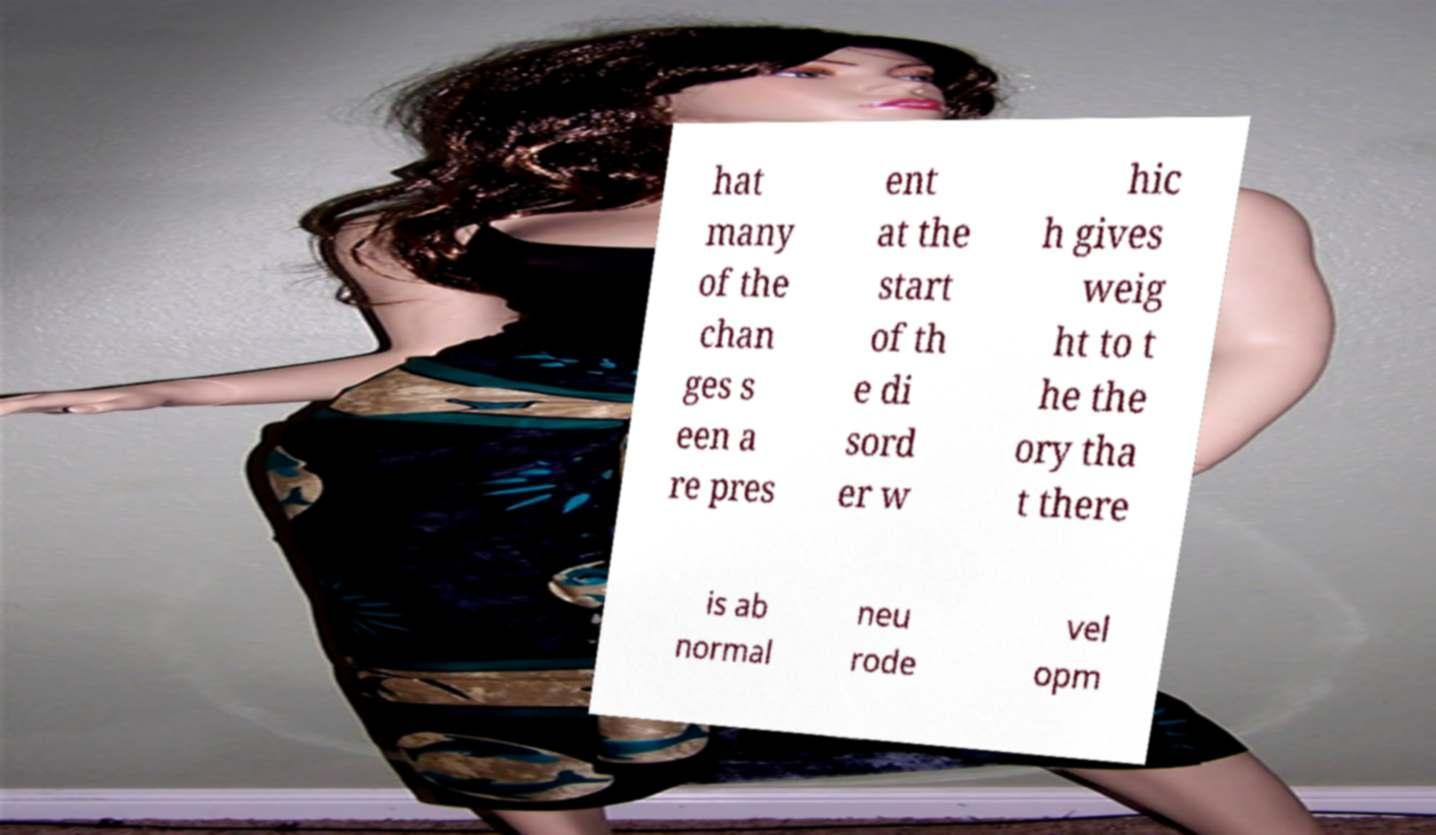Please read and relay the text visible in this image. What does it say? hat many of the chan ges s een a re pres ent at the start of th e di sord er w hic h gives weig ht to t he the ory tha t there is ab normal neu rode vel opm 